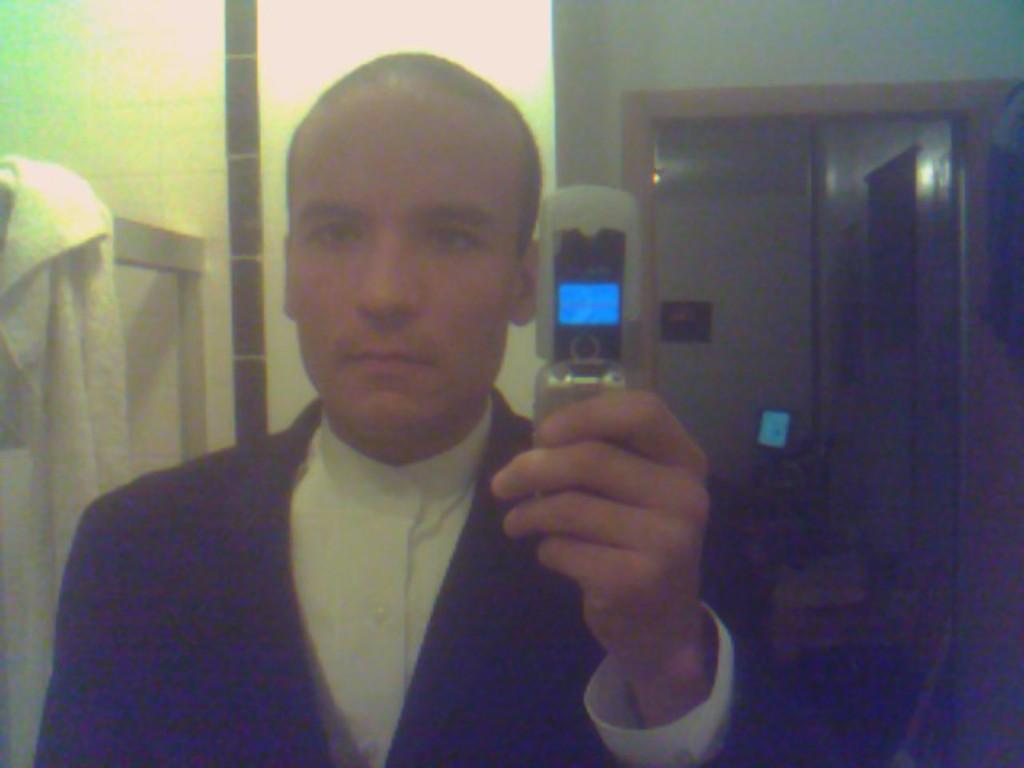How would you summarize this image in a sentence or two? In this image I see a man who is wearing white and black dress and I see that he is holding a phone in his hand. In the background I see the towel over here and I see the wall and it is dark over here. 